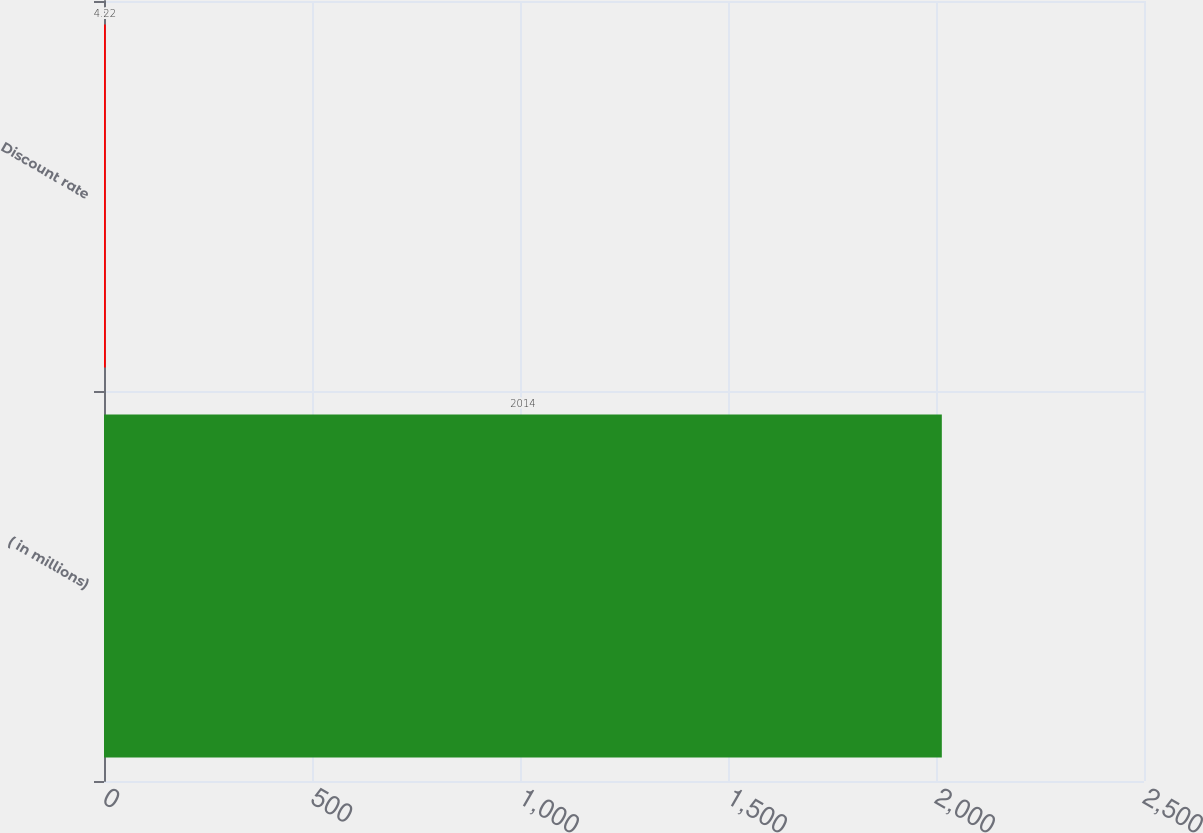Convert chart to OTSL. <chart><loc_0><loc_0><loc_500><loc_500><bar_chart><fcel>( in millions)<fcel>Discount rate<nl><fcel>2014<fcel>4.22<nl></chart> 